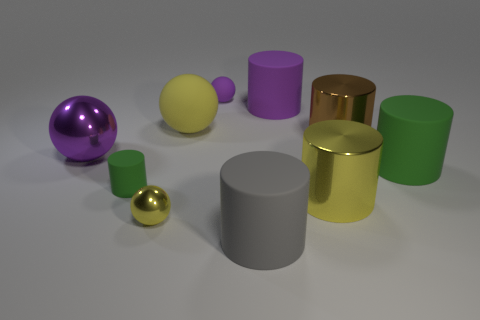What number of purple metallic balls are to the left of the large purple ball?
Provide a succinct answer. 0. Is the material of the big yellow cylinder the same as the large green thing?
Offer a very short reply. No. How many purple things are both on the left side of the small matte cylinder and behind the large brown object?
Ensure brevity in your answer.  0. What number of other objects are there of the same color as the tiny shiny object?
Your response must be concise. 2. How many brown things are either large shiny balls or big things?
Provide a succinct answer. 1. The yellow cylinder is what size?
Your response must be concise. Large. What number of matte things are big cyan blocks or small purple balls?
Provide a succinct answer. 1. Is the number of tiny yellow metal things less than the number of large blue metal spheres?
Your answer should be very brief. No. How many other things are the same material as the big purple sphere?
Offer a terse response. 3. The yellow metal object that is the same shape as the purple shiny object is what size?
Offer a terse response. Small. 